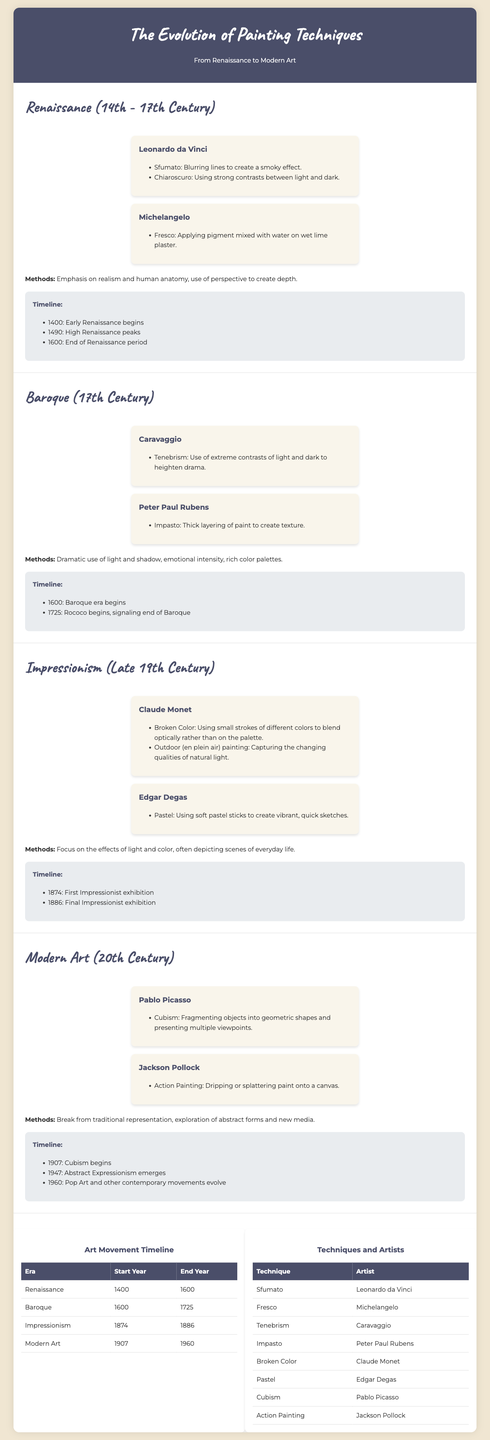What technique did Leonardo da Vinci pioneer? Leonardo da Vinci is known for pioneering the technique called Sfumato.
Answer: Sfumato Which artist used the fresco technique? The document states that Michelangelo applied pigment mixed with water on wet lime plaster, which is known as fresco.
Answer: Michelangelo What year did Impressionism start? The first Impressionist exhibition took place in 1874, marking the start of the Impressionism era.
Answer: 1874 Which technique is associated with Jackson Pollock? The document notes that Jackson Pollock is known for Action Painting, which involves dripping or splattering paint.
Answer: Action Painting What does the term "Impressionism" refer to in the context of painting? Impressionism refers to the focus on light effects and color, often depicting scenes of everyday life, as detailed in the methods section.
Answer: Focus on light and color How many artists are listed under the Baroque era? The document presents two key artists from the Baroque era: Caravaggio and Peter Paul Rubens.
Answer: Two Which movement began in 1907? The document indicates that Cubism began in 1907.
Answer: Cubism Which two techniques are linked with Claude Monet? The techniques broken color and outdoor painting (en plein air) are linked with Claude Monet in the document.
Answer: Broken Color and outdoor painting When did the Renaissance period end? According to the timeline, the Renaissance period ended in 1600.
Answer: 1600 